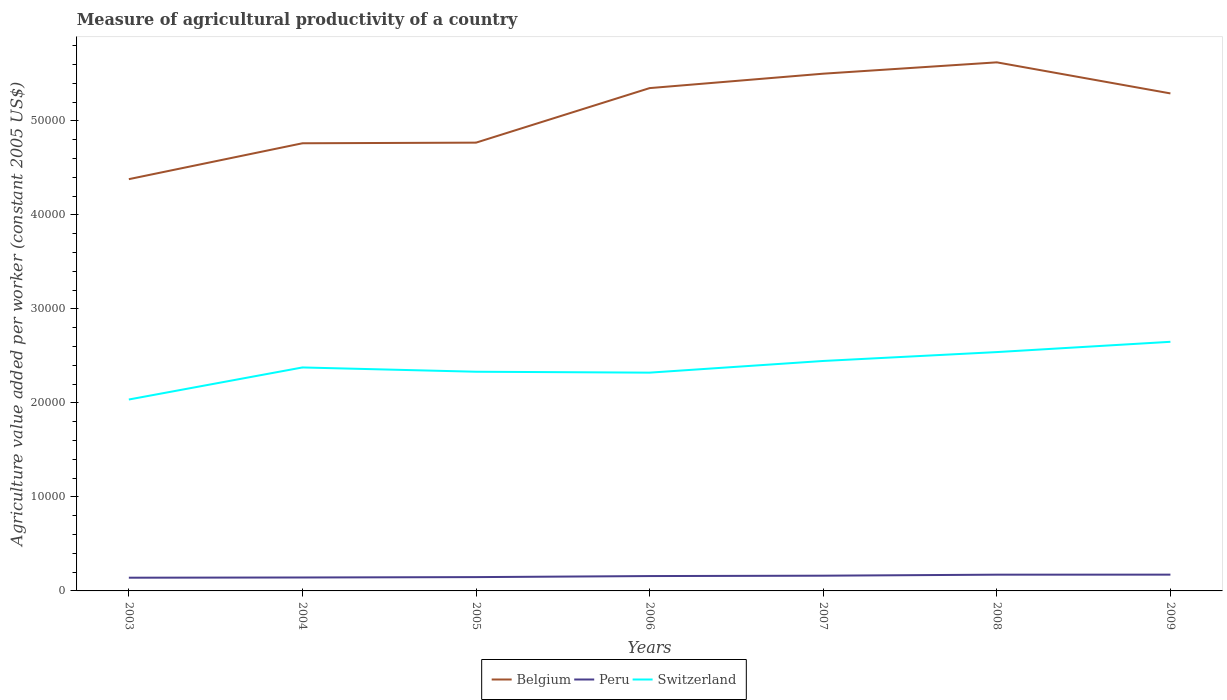Across all years, what is the maximum measure of agricultural productivity in Switzerland?
Give a very brief answer. 2.04e+04. In which year was the measure of agricultural productivity in Belgium maximum?
Your answer should be compact. 2003. What is the total measure of agricultural productivity in Switzerland in the graph?
Your answer should be compact. -2090.52. What is the difference between the highest and the second highest measure of agricultural productivity in Belgium?
Your answer should be compact. 1.24e+04. How many years are there in the graph?
Your response must be concise. 7. What is the difference between two consecutive major ticks on the Y-axis?
Offer a terse response. 10000. Are the values on the major ticks of Y-axis written in scientific E-notation?
Offer a terse response. No. What is the title of the graph?
Give a very brief answer. Measure of agricultural productivity of a country. What is the label or title of the Y-axis?
Your response must be concise. Agriculture value added per worker (constant 2005 US$). What is the Agriculture value added per worker (constant 2005 US$) in Belgium in 2003?
Keep it short and to the point. 4.38e+04. What is the Agriculture value added per worker (constant 2005 US$) in Peru in 2003?
Your answer should be very brief. 1405.11. What is the Agriculture value added per worker (constant 2005 US$) of Switzerland in 2003?
Offer a terse response. 2.04e+04. What is the Agriculture value added per worker (constant 2005 US$) of Belgium in 2004?
Make the answer very short. 4.76e+04. What is the Agriculture value added per worker (constant 2005 US$) of Peru in 2004?
Offer a very short reply. 1429.65. What is the Agriculture value added per worker (constant 2005 US$) in Switzerland in 2004?
Give a very brief answer. 2.38e+04. What is the Agriculture value added per worker (constant 2005 US$) of Belgium in 2005?
Your response must be concise. 4.77e+04. What is the Agriculture value added per worker (constant 2005 US$) of Peru in 2005?
Provide a short and direct response. 1468.91. What is the Agriculture value added per worker (constant 2005 US$) in Switzerland in 2005?
Keep it short and to the point. 2.33e+04. What is the Agriculture value added per worker (constant 2005 US$) in Belgium in 2006?
Offer a very short reply. 5.35e+04. What is the Agriculture value added per worker (constant 2005 US$) of Peru in 2006?
Your response must be concise. 1580.11. What is the Agriculture value added per worker (constant 2005 US$) of Switzerland in 2006?
Give a very brief answer. 2.32e+04. What is the Agriculture value added per worker (constant 2005 US$) of Belgium in 2007?
Your response must be concise. 5.50e+04. What is the Agriculture value added per worker (constant 2005 US$) in Peru in 2007?
Provide a succinct answer. 1620.17. What is the Agriculture value added per worker (constant 2005 US$) in Switzerland in 2007?
Ensure brevity in your answer.  2.45e+04. What is the Agriculture value added per worker (constant 2005 US$) of Belgium in 2008?
Provide a short and direct response. 5.62e+04. What is the Agriculture value added per worker (constant 2005 US$) of Peru in 2008?
Give a very brief answer. 1728.53. What is the Agriculture value added per worker (constant 2005 US$) of Switzerland in 2008?
Provide a succinct answer. 2.54e+04. What is the Agriculture value added per worker (constant 2005 US$) of Belgium in 2009?
Your answer should be compact. 5.29e+04. What is the Agriculture value added per worker (constant 2005 US$) in Peru in 2009?
Your answer should be compact. 1731.8. What is the Agriculture value added per worker (constant 2005 US$) of Switzerland in 2009?
Provide a succinct answer. 2.65e+04. Across all years, what is the maximum Agriculture value added per worker (constant 2005 US$) in Belgium?
Make the answer very short. 5.62e+04. Across all years, what is the maximum Agriculture value added per worker (constant 2005 US$) of Peru?
Give a very brief answer. 1731.8. Across all years, what is the maximum Agriculture value added per worker (constant 2005 US$) in Switzerland?
Make the answer very short. 2.65e+04. Across all years, what is the minimum Agriculture value added per worker (constant 2005 US$) in Belgium?
Give a very brief answer. 4.38e+04. Across all years, what is the minimum Agriculture value added per worker (constant 2005 US$) of Peru?
Offer a very short reply. 1405.11. Across all years, what is the minimum Agriculture value added per worker (constant 2005 US$) in Switzerland?
Give a very brief answer. 2.04e+04. What is the total Agriculture value added per worker (constant 2005 US$) in Belgium in the graph?
Provide a succinct answer. 3.57e+05. What is the total Agriculture value added per worker (constant 2005 US$) in Peru in the graph?
Your answer should be compact. 1.10e+04. What is the total Agriculture value added per worker (constant 2005 US$) of Switzerland in the graph?
Make the answer very short. 1.67e+05. What is the difference between the Agriculture value added per worker (constant 2005 US$) in Belgium in 2003 and that in 2004?
Your answer should be compact. -3816.6. What is the difference between the Agriculture value added per worker (constant 2005 US$) in Peru in 2003 and that in 2004?
Provide a succinct answer. -24.54. What is the difference between the Agriculture value added per worker (constant 2005 US$) in Switzerland in 2003 and that in 2004?
Offer a very short reply. -3411.15. What is the difference between the Agriculture value added per worker (constant 2005 US$) in Belgium in 2003 and that in 2005?
Offer a very short reply. -3883.5. What is the difference between the Agriculture value added per worker (constant 2005 US$) of Peru in 2003 and that in 2005?
Give a very brief answer. -63.8. What is the difference between the Agriculture value added per worker (constant 2005 US$) in Switzerland in 2003 and that in 2005?
Your response must be concise. -2954.77. What is the difference between the Agriculture value added per worker (constant 2005 US$) in Belgium in 2003 and that in 2006?
Keep it short and to the point. -9684.39. What is the difference between the Agriculture value added per worker (constant 2005 US$) of Peru in 2003 and that in 2006?
Your response must be concise. -175. What is the difference between the Agriculture value added per worker (constant 2005 US$) of Switzerland in 2003 and that in 2006?
Provide a succinct answer. -2858.29. What is the difference between the Agriculture value added per worker (constant 2005 US$) of Belgium in 2003 and that in 2007?
Keep it short and to the point. -1.12e+04. What is the difference between the Agriculture value added per worker (constant 2005 US$) in Peru in 2003 and that in 2007?
Your answer should be very brief. -215.07. What is the difference between the Agriculture value added per worker (constant 2005 US$) in Switzerland in 2003 and that in 2007?
Offer a terse response. -4101.01. What is the difference between the Agriculture value added per worker (constant 2005 US$) of Belgium in 2003 and that in 2008?
Offer a very short reply. -1.24e+04. What is the difference between the Agriculture value added per worker (constant 2005 US$) of Peru in 2003 and that in 2008?
Provide a succinct answer. -323.43. What is the difference between the Agriculture value added per worker (constant 2005 US$) in Switzerland in 2003 and that in 2008?
Provide a short and direct response. -5045.29. What is the difference between the Agriculture value added per worker (constant 2005 US$) of Belgium in 2003 and that in 2009?
Ensure brevity in your answer.  -9119.14. What is the difference between the Agriculture value added per worker (constant 2005 US$) of Peru in 2003 and that in 2009?
Your response must be concise. -326.69. What is the difference between the Agriculture value added per worker (constant 2005 US$) of Switzerland in 2003 and that in 2009?
Provide a succinct answer. -6139.39. What is the difference between the Agriculture value added per worker (constant 2005 US$) in Belgium in 2004 and that in 2005?
Make the answer very short. -66.9. What is the difference between the Agriculture value added per worker (constant 2005 US$) of Peru in 2004 and that in 2005?
Your response must be concise. -39.26. What is the difference between the Agriculture value added per worker (constant 2005 US$) in Switzerland in 2004 and that in 2005?
Ensure brevity in your answer.  456.39. What is the difference between the Agriculture value added per worker (constant 2005 US$) in Belgium in 2004 and that in 2006?
Keep it short and to the point. -5867.79. What is the difference between the Agriculture value added per worker (constant 2005 US$) in Peru in 2004 and that in 2006?
Give a very brief answer. -150.46. What is the difference between the Agriculture value added per worker (constant 2005 US$) of Switzerland in 2004 and that in 2006?
Your response must be concise. 552.86. What is the difference between the Agriculture value added per worker (constant 2005 US$) of Belgium in 2004 and that in 2007?
Provide a succinct answer. -7400.8. What is the difference between the Agriculture value added per worker (constant 2005 US$) in Peru in 2004 and that in 2007?
Ensure brevity in your answer.  -190.53. What is the difference between the Agriculture value added per worker (constant 2005 US$) in Switzerland in 2004 and that in 2007?
Make the answer very short. -689.86. What is the difference between the Agriculture value added per worker (constant 2005 US$) in Belgium in 2004 and that in 2008?
Keep it short and to the point. -8607.5. What is the difference between the Agriculture value added per worker (constant 2005 US$) in Peru in 2004 and that in 2008?
Make the answer very short. -298.89. What is the difference between the Agriculture value added per worker (constant 2005 US$) of Switzerland in 2004 and that in 2008?
Make the answer very short. -1634.13. What is the difference between the Agriculture value added per worker (constant 2005 US$) of Belgium in 2004 and that in 2009?
Your answer should be very brief. -5302.54. What is the difference between the Agriculture value added per worker (constant 2005 US$) of Peru in 2004 and that in 2009?
Offer a terse response. -302.15. What is the difference between the Agriculture value added per worker (constant 2005 US$) in Switzerland in 2004 and that in 2009?
Keep it short and to the point. -2728.24. What is the difference between the Agriculture value added per worker (constant 2005 US$) of Belgium in 2005 and that in 2006?
Offer a very short reply. -5800.89. What is the difference between the Agriculture value added per worker (constant 2005 US$) in Peru in 2005 and that in 2006?
Provide a short and direct response. -111.2. What is the difference between the Agriculture value added per worker (constant 2005 US$) of Switzerland in 2005 and that in 2006?
Provide a short and direct response. 96.47. What is the difference between the Agriculture value added per worker (constant 2005 US$) in Belgium in 2005 and that in 2007?
Provide a succinct answer. -7333.89. What is the difference between the Agriculture value added per worker (constant 2005 US$) in Peru in 2005 and that in 2007?
Your response must be concise. -151.27. What is the difference between the Agriculture value added per worker (constant 2005 US$) in Switzerland in 2005 and that in 2007?
Your answer should be very brief. -1146.24. What is the difference between the Agriculture value added per worker (constant 2005 US$) of Belgium in 2005 and that in 2008?
Your answer should be very brief. -8540.59. What is the difference between the Agriculture value added per worker (constant 2005 US$) of Peru in 2005 and that in 2008?
Keep it short and to the point. -259.63. What is the difference between the Agriculture value added per worker (constant 2005 US$) of Switzerland in 2005 and that in 2008?
Make the answer very short. -2090.52. What is the difference between the Agriculture value added per worker (constant 2005 US$) of Belgium in 2005 and that in 2009?
Your answer should be compact. -5235.64. What is the difference between the Agriculture value added per worker (constant 2005 US$) in Peru in 2005 and that in 2009?
Your answer should be compact. -262.89. What is the difference between the Agriculture value added per worker (constant 2005 US$) in Switzerland in 2005 and that in 2009?
Offer a very short reply. -3184.63. What is the difference between the Agriculture value added per worker (constant 2005 US$) in Belgium in 2006 and that in 2007?
Your answer should be compact. -1533.01. What is the difference between the Agriculture value added per worker (constant 2005 US$) of Peru in 2006 and that in 2007?
Your answer should be compact. -40.07. What is the difference between the Agriculture value added per worker (constant 2005 US$) in Switzerland in 2006 and that in 2007?
Keep it short and to the point. -1242.72. What is the difference between the Agriculture value added per worker (constant 2005 US$) of Belgium in 2006 and that in 2008?
Provide a short and direct response. -2739.71. What is the difference between the Agriculture value added per worker (constant 2005 US$) of Peru in 2006 and that in 2008?
Your answer should be very brief. -148.43. What is the difference between the Agriculture value added per worker (constant 2005 US$) in Switzerland in 2006 and that in 2008?
Give a very brief answer. -2186.99. What is the difference between the Agriculture value added per worker (constant 2005 US$) of Belgium in 2006 and that in 2009?
Provide a succinct answer. 565.25. What is the difference between the Agriculture value added per worker (constant 2005 US$) in Peru in 2006 and that in 2009?
Provide a succinct answer. -151.69. What is the difference between the Agriculture value added per worker (constant 2005 US$) of Switzerland in 2006 and that in 2009?
Your answer should be very brief. -3281.1. What is the difference between the Agriculture value added per worker (constant 2005 US$) in Belgium in 2007 and that in 2008?
Provide a short and direct response. -1206.7. What is the difference between the Agriculture value added per worker (constant 2005 US$) of Peru in 2007 and that in 2008?
Offer a very short reply. -108.36. What is the difference between the Agriculture value added per worker (constant 2005 US$) of Switzerland in 2007 and that in 2008?
Offer a terse response. -944.28. What is the difference between the Agriculture value added per worker (constant 2005 US$) of Belgium in 2007 and that in 2009?
Offer a very short reply. 2098.26. What is the difference between the Agriculture value added per worker (constant 2005 US$) in Peru in 2007 and that in 2009?
Provide a succinct answer. -111.62. What is the difference between the Agriculture value added per worker (constant 2005 US$) in Switzerland in 2007 and that in 2009?
Keep it short and to the point. -2038.38. What is the difference between the Agriculture value added per worker (constant 2005 US$) in Belgium in 2008 and that in 2009?
Your answer should be very brief. 3304.95. What is the difference between the Agriculture value added per worker (constant 2005 US$) in Peru in 2008 and that in 2009?
Keep it short and to the point. -3.26. What is the difference between the Agriculture value added per worker (constant 2005 US$) of Switzerland in 2008 and that in 2009?
Provide a succinct answer. -1094.11. What is the difference between the Agriculture value added per worker (constant 2005 US$) of Belgium in 2003 and the Agriculture value added per worker (constant 2005 US$) of Peru in 2004?
Give a very brief answer. 4.24e+04. What is the difference between the Agriculture value added per worker (constant 2005 US$) in Belgium in 2003 and the Agriculture value added per worker (constant 2005 US$) in Switzerland in 2004?
Your response must be concise. 2.00e+04. What is the difference between the Agriculture value added per worker (constant 2005 US$) of Peru in 2003 and the Agriculture value added per worker (constant 2005 US$) of Switzerland in 2004?
Your answer should be very brief. -2.24e+04. What is the difference between the Agriculture value added per worker (constant 2005 US$) in Belgium in 2003 and the Agriculture value added per worker (constant 2005 US$) in Peru in 2005?
Provide a succinct answer. 4.23e+04. What is the difference between the Agriculture value added per worker (constant 2005 US$) in Belgium in 2003 and the Agriculture value added per worker (constant 2005 US$) in Switzerland in 2005?
Your answer should be compact. 2.05e+04. What is the difference between the Agriculture value added per worker (constant 2005 US$) of Peru in 2003 and the Agriculture value added per worker (constant 2005 US$) of Switzerland in 2005?
Provide a short and direct response. -2.19e+04. What is the difference between the Agriculture value added per worker (constant 2005 US$) in Belgium in 2003 and the Agriculture value added per worker (constant 2005 US$) in Peru in 2006?
Your answer should be very brief. 4.22e+04. What is the difference between the Agriculture value added per worker (constant 2005 US$) in Belgium in 2003 and the Agriculture value added per worker (constant 2005 US$) in Switzerland in 2006?
Give a very brief answer. 2.06e+04. What is the difference between the Agriculture value added per worker (constant 2005 US$) of Peru in 2003 and the Agriculture value added per worker (constant 2005 US$) of Switzerland in 2006?
Your answer should be very brief. -2.18e+04. What is the difference between the Agriculture value added per worker (constant 2005 US$) of Belgium in 2003 and the Agriculture value added per worker (constant 2005 US$) of Peru in 2007?
Offer a terse response. 4.22e+04. What is the difference between the Agriculture value added per worker (constant 2005 US$) of Belgium in 2003 and the Agriculture value added per worker (constant 2005 US$) of Switzerland in 2007?
Ensure brevity in your answer.  1.93e+04. What is the difference between the Agriculture value added per worker (constant 2005 US$) of Peru in 2003 and the Agriculture value added per worker (constant 2005 US$) of Switzerland in 2007?
Make the answer very short. -2.31e+04. What is the difference between the Agriculture value added per worker (constant 2005 US$) of Belgium in 2003 and the Agriculture value added per worker (constant 2005 US$) of Peru in 2008?
Offer a terse response. 4.21e+04. What is the difference between the Agriculture value added per worker (constant 2005 US$) in Belgium in 2003 and the Agriculture value added per worker (constant 2005 US$) in Switzerland in 2008?
Your answer should be very brief. 1.84e+04. What is the difference between the Agriculture value added per worker (constant 2005 US$) of Peru in 2003 and the Agriculture value added per worker (constant 2005 US$) of Switzerland in 2008?
Offer a terse response. -2.40e+04. What is the difference between the Agriculture value added per worker (constant 2005 US$) in Belgium in 2003 and the Agriculture value added per worker (constant 2005 US$) in Peru in 2009?
Provide a succinct answer. 4.21e+04. What is the difference between the Agriculture value added per worker (constant 2005 US$) in Belgium in 2003 and the Agriculture value added per worker (constant 2005 US$) in Switzerland in 2009?
Provide a short and direct response. 1.73e+04. What is the difference between the Agriculture value added per worker (constant 2005 US$) of Peru in 2003 and the Agriculture value added per worker (constant 2005 US$) of Switzerland in 2009?
Provide a succinct answer. -2.51e+04. What is the difference between the Agriculture value added per worker (constant 2005 US$) in Belgium in 2004 and the Agriculture value added per worker (constant 2005 US$) in Peru in 2005?
Provide a short and direct response. 4.61e+04. What is the difference between the Agriculture value added per worker (constant 2005 US$) in Belgium in 2004 and the Agriculture value added per worker (constant 2005 US$) in Switzerland in 2005?
Your answer should be compact. 2.43e+04. What is the difference between the Agriculture value added per worker (constant 2005 US$) of Peru in 2004 and the Agriculture value added per worker (constant 2005 US$) of Switzerland in 2005?
Your response must be concise. -2.19e+04. What is the difference between the Agriculture value added per worker (constant 2005 US$) of Belgium in 2004 and the Agriculture value added per worker (constant 2005 US$) of Peru in 2006?
Your answer should be compact. 4.60e+04. What is the difference between the Agriculture value added per worker (constant 2005 US$) in Belgium in 2004 and the Agriculture value added per worker (constant 2005 US$) in Switzerland in 2006?
Offer a very short reply. 2.44e+04. What is the difference between the Agriculture value added per worker (constant 2005 US$) of Peru in 2004 and the Agriculture value added per worker (constant 2005 US$) of Switzerland in 2006?
Your answer should be very brief. -2.18e+04. What is the difference between the Agriculture value added per worker (constant 2005 US$) of Belgium in 2004 and the Agriculture value added per worker (constant 2005 US$) of Peru in 2007?
Provide a short and direct response. 4.60e+04. What is the difference between the Agriculture value added per worker (constant 2005 US$) of Belgium in 2004 and the Agriculture value added per worker (constant 2005 US$) of Switzerland in 2007?
Your response must be concise. 2.32e+04. What is the difference between the Agriculture value added per worker (constant 2005 US$) in Peru in 2004 and the Agriculture value added per worker (constant 2005 US$) in Switzerland in 2007?
Give a very brief answer. -2.30e+04. What is the difference between the Agriculture value added per worker (constant 2005 US$) in Belgium in 2004 and the Agriculture value added per worker (constant 2005 US$) in Peru in 2008?
Offer a very short reply. 4.59e+04. What is the difference between the Agriculture value added per worker (constant 2005 US$) in Belgium in 2004 and the Agriculture value added per worker (constant 2005 US$) in Switzerland in 2008?
Your answer should be compact. 2.22e+04. What is the difference between the Agriculture value added per worker (constant 2005 US$) in Peru in 2004 and the Agriculture value added per worker (constant 2005 US$) in Switzerland in 2008?
Provide a succinct answer. -2.40e+04. What is the difference between the Agriculture value added per worker (constant 2005 US$) in Belgium in 2004 and the Agriculture value added per worker (constant 2005 US$) in Peru in 2009?
Your answer should be very brief. 4.59e+04. What is the difference between the Agriculture value added per worker (constant 2005 US$) of Belgium in 2004 and the Agriculture value added per worker (constant 2005 US$) of Switzerland in 2009?
Ensure brevity in your answer.  2.11e+04. What is the difference between the Agriculture value added per worker (constant 2005 US$) in Peru in 2004 and the Agriculture value added per worker (constant 2005 US$) in Switzerland in 2009?
Your response must be concise. -2.51e+04. What is the difference between the Agriculture value added per worker (constant 2005 US$) in Belgium in 2005 and the Agriculture value added per worker (constant 2005 US$) in Peru in 2006?
Provide a short and direct response. 4.61e+04. What is the difference between the Agriculture value added per worker (constant 2005 US$) of Belgium in 2005 and the Agriculture value added per worker (constant 2005 US$) of Switzerland in 2006?
Provide a succinct answer. 2.45e+04. What is the difference between the Agriculture value added per worker (constant 2005 US$) in Peru in 2005 and the Agriculture value added per worker (constant 2005 US$) in Switzerland in 2006?
Ensure brevity in your answer.  -2.17e+04. What is the difference between the Agriculture value added per worker (constant 2005 US$) in Belgium in 2005 and the Agriculture value added per worker (constant 2005 US$) in Peru in 2007?
Your answer should be compact. 4.61e+04. What is the difference between the Agriculture value added per worker (constant 2005 US$) in Belgium in 2005 and the Agriculture value added per worker (constant 2005 US$) in Switzerland in 2007?
Provide a succinct answer. 2.32e+04. What is the difference between the Agriculture value added per worker (constant 2005 US$) in Peru in 2005 and the Agriculture value added per worker (constant 2005 US$) in Switzerland in 2007?
Your answer should be compact. -2.30e+04. What is the difference between the Agriculture value added per worker (constant 2005 US$) in Belgium in 2005 and the Agriculture value added per worker (constant 2005 US$) in Peru in 2008?
Your answer should be very brief. 4.59e+04. What is the difference between the Agriculture value added per worker (constant 2005 US$) of Belgium in 2005 and the Agriculture value added per worker (constant 2005 US$) of Switzerland in 2008?
Offer a terse response. 2.23e+04. What is the difference between the Agriculture value added per worker (constant 2005 US$) of Peru in 2005 and the Agriculture value added per worker (constant 2005 US$) of Switzerland in 2008?
Your response must be concise. -2.39e+04. What is the difference between the Agriculture value added per worker (constant 2005 US$) in Belgium in 2005 and the Agriculture value added per worker (constant 2005 US$) in Peru in 2009?
Ensure brevity in your answer.  4.59e+04. What is the difference between the Agriculture value added per worker (constant 2005 US$) in Belgium in 2005 and the Agriculture value added per worker (constant 2005 US$) in Switzerland in 2009?
Your answer should be very brief. 2.12e+04. What is the difference between the Agriculture value added per worker (constant 2005 US$) of Peru in 2005 and the Agriculture value added per worker (constant 2005 US$) of Switzerland in 2009?
Your response must be concise. -2.50e+04. What is the difference between the Agriculture value added per worker (constant 2005 US$) of Belgium in 2006 and the Agriculture value added per worker (constant 2005 US$) of Peru in 2007?
Make the answer very short. 5.19e+04. What is the difference between the Agriculture value added per worker (constant 2005 US$) in Belgium in 2006 and the Agriculture value added per worker (constant 2005 US$) in Switzerland in 2007?
Offer a very short reply. 2.90e+04. What is the difference between the Agriculture value added per worker (constant 2005 US$) in Peru in 2006 and the Agriculture value added per worker (constant 2005 US$) in Switzerland in 2007?
Provide a succinct answer. -2.29e+04. What is the difference between the Agriculture value added per worker (constant 2005 US$) of Belgium in 2006 and the Agriculture value added per worker (constant 2005 US$) of Peru in 2008?
Your answer should be compact. 5.18e+04. What is the difference between the Agriculture value added per worker (constant 2005 US$) of Belgium in 2006 and the Agriculture value added per worker (constant 2005 US$) of Switzerland in 2008?
Give a very brief answer. 2.81e+04. What is the difference between the Agriculture value added per worker (constant 2005 US$) in Peru in 2006 and the Agriculture value added per worker (constant 2005 US$) in Switzerland in 2008?
Give a very brief answer. -2.38e+04. What is the difference between the Agriculture value added per worker (constant 2005 US$) of Belgium in 2006 and the Agriculture value added per worker (constant 2005 US$) of Peru in 2009?
Provide a short and direct response. 5.17e+04. What is the difference between the Agriculture value added per worker (constant 2005 US$) in Belgium in 2006 and the Agriculture value added per worker (constant 2005 US$) in Switzerland in 2009?
Your answer should be very brief. 2.70e+04. What is the difference between the Agriculture value added per worker (constant 2005 US$) in Peru in 2006 and the Agriculture value added per worker (constant 2005 US$) in Switzerland in 2009?
Give a very brief answer. -2.49e+04. What is the difference between the Agriculture value added per worker (constant 2005 US$) in Belgium in 2007 and the Agriculture value added per worker (constant 2005 US$) in Peru in 2008?
Your answer should be compact. 5.33e+04. What is the difference between the Agriculture value added per worker (constant 2005 US$) in Belgium in 2007 and the Agriculture value added per worker (constant 2005 US$) in Switzerland in 2008?
Your response must be concise. 2.96e+04. What is the difference between the Agriculture value added per worker (constant 2005 US$) of Peru in 2007 and the Agriculture value added per worker (constant 2005 US$) of Switzerland in 2008?
Give a very brief answer. -2.38e+04. What is the difference between the Agriculture value added per worker (constant 2005 US$) of Belgium in 2007 and the Agriculture value added per worker (constant 2005 US$) of Peru in 2009?
Offer a terse response. 5.33e+04. What is the difference between the Agriculture value added per worker (constant 2005 US$) of Belgium in 2007 and the Agriculture value added per worker (constant 2005 US$) of Switzerland in 2009?
Give a very brief answer. 2.85e+04. What is the difference between the Agriculture value added per worker (constant 2005 US$) of Peru in 2007 and the Agriculture value added per worker (constant 2005 US$) of Switzerland in 2009?
Your answer should be very brief. -2.49e+04. What is the difference between the Agriculture value added per worker (constant 2005 US$) in Belgium in 2008 and the Agriculture value added per worker (constant 2005 US$) in Peru in 2009?
Your answer should be compact. 5.45e+04. What is the difference between the Agriculture value added per worker (constant 2005 US$) in Belgium in 2008 and the Agriculture value added per worker (constant 2005 US$) in Switzerland in 2009?
Provide a succinct answer. 2.97e+04. What is the difference between the Agriculture value added per worker (constant 2005 US$) in Peru in 2008 and the Agriculture value added per worker (constant 2005 US$) in Switzerland in 2009?
Provide a short and direct response. -2.48e+04. What is the average Agriculture value added per worker (constant 2005 US$) of Belgium per year?
Offer a very short reply. 5.10e+04. What is the average Agriculture value added per worker (constant 2005 US$) in Peru per year?
Make the answer very short. 1566.32. What is the average Agriculture value added per worker (constant 2005 US$) of Switzerland per year?
Give a very brief answer. 2.39e+04. In the year 2003, what is the difference between the Agriculture value added per worker (constant 2005 US$) of Belgium and Agriculture value added per worker (constant 2005 US$) of Peru?
Provide a succinct answer. 4.24e+04. In the year 2003, what is the difference between the Agriculture value added per worker (constant 2005 US$) of Belgium and Agriculture value added per worker (constant 2005 US$) of Switzerland?
Your answer should be very brief. 2.34e+04. In the year 2003, what is the difference between the Agriculture value added per worker (constant 2005 US$) in Peru and Agriculture value added per worker (constant 2005 US$) in Switzerland?
Make the answer very short. -1.90e+04. In the year 2004, what is the difference between the Agriculture value added per worker (constant 2005 US$) of Belgium and Agriculture value added per worker (constant 2005 US$) of Peru?
Keep it short and to the point. 4.62e+04. In the year 2004, what is the difference between the Agriculture value added per worker (constant 2005 US$) in Belgium and Agriculture value added per worker (constant 2005 US$) in Switzerland?
Offer a very short reply. 2.38e+04. In the year 2004, what is the difference between the Agriculture value added per worker (constant 2005 US$) of Peru and Agriculture value added per worker (constant 2005 US$) of Switzerland?
Ensure brevity in your answer.  -2.23e+04. In the year 2005, what is the difference between the Agriculture value added per worker (constant 2005 US$) of Belgium and Agriculture value added per worker (constant 2005 US$) of Peru?
Your answer should be very brief. 4.62e+04. In the year 2005, what is the difference between the Agriculture value added per worker (constant 2005 US$) of Belgium and Agriculture value added per worker (constant 2005 US$) of Switzerland?
Your answer should be very brief. 2.44e+04. In the year 2005, what is the difference between the Agriculture value added per worker (constant 2005 US$) in Peru and Agriculture value added per worker (constant 2005 US$) in Switzerland?
Provide a short and direct response. -2.18e+04. In the year 2006, what is the difference between the Agriculture value added per worker (constant 2005 US$) in Belgium and Agriculture value added per worker (constant 2005 US$) in Peru?
Offer a very short reply. 5.19e+04. In the year 2006, what is the difference between the Agriculture value added per worker (constant 2005 US$) of Belgium and Agriculture value added per worker (constant 2005 US$) of Switzerland?
Provide a succinct answer. 3.03e+04. In the year 2006, what is the difference between the Agriculture value added per worker (constant 2005 US$) in Peru and Agriculture value added per worker (constant 2005 US$) in Switzerland?
Your answer should be compact. -2.16e+04. In the year 2007, what is the difference between the Agriculture value added per worker (constant 2005 US$) of Belgium and Agriculture value added per worker (constant 2005 US$) of Peru?
Ensure brevity in your answer.  5.34e+04. In the year 2007, what is the difference between the Agriculture value added per worker (constant 2005 US$) of Belgium and Agriculture value added per worker (constant 2005 US$) of Switzerland?
Offer a terse response. 3.06e+04. In the year 2007, what is the difference between the Agriculture value added per worker (constant 2005 US$) in Peru and Agriculture value added per worker (constant 2005 US$) in Switzerland?
Ensure brevity in your answer.  -2.28e+04. In the year 2008, what is the difference between the Agriculture value added per worker (constant 2005 US$) in Belgium and Agriculture value added per worker (constant 2005 US$) in Peru?
Give a very brief answer. 5.45e+04. In the year 2008, what is the difference between the Agriculture value added per worker (constant 2005 US$) in Belgium and Agriculture value added per worker (constant 2005 US$) in Switzerland?
Provide a succinct answer. 3.08e+04. In the year 2008, what is the difference between the Agriculture value added per worker (constant 2005 US$) in Peru and Agriculture value added per worker (constant 2005 US$) in Switzerland?
Ensure brevity in your answer.  -2.37e+04. In the year 2009, what is the difference between the Agriculture value added per worker (constant 2005 US$) in Belgium and Agriculture value added per worker (constant 2005 US$) in Peru?
Ensure brevity in your answer.  5.12e+04. In the year 2009, what is the difference between the Agriculture value added per worker (constant 2005 US$) in Belgium and Agriculture value added per worker (constant 2005 US$) in Switzerland?
Ensure brevity in your answer.  2.64e+04. In the year 2009, what is the difference between the Agriculture value added per worker (constant 2005 US$) in Peru and Agriculture value added per worker (constant 2005 US$) in Switzerland?
Your answer should be compact. -2.48e+04. What is the ratio of the Agriculture value added per worker (constant 2005 US$) in Belgium in 2003 to that in 2004?
Provide a short and direct response. 0.92. What is the ratio of the Agriculture value added per worker (constant 2005 US$) of Peru in 2003 to that in 2004?
Offer a very short reply. 0.98. What is the ratio of the Agriculture value added per worker (constant 2005 US$) in Switzerland in 2003 to that in 2004?
Give a very brief answer. 0.86. What is the ratio of the Agriculture value added per worker (constant 2005 US$) in Belgium in 2003 to that in 2005?
Keep it short and to the point. 0.92. What is the ratio of the Agriculture value added per worker (constant 2005 US$) of Peru in 2003 to that in 2005?
Make the answer very short. 0.96. What is the ratio of the Agriculture value added per worker (constant 2005 US$) in Switzerland in 2003 to that in 2005?
Offer a terse response. 0.87. What is the ratio of the Agriculture value added per worker (constant 2005 US$) in Belgium in 2003 to that in 2006?
Offer a terse response. 0.82. What is the ratio of the Agriculture value added per worker (constant 2005 US$) of Peru in 2003 to that in 2006?
Offer a very short reply. 0.89. What is the ratio of the Agriculture value added per worker (constant 2005 US$) in Switzerland in 2003 to that in 2006?
Your answer should be compact. 0.88. What is the ratio of the Agriculture value added per worker (constant 2005 US$) in Belgium in 2003 to that in 2007?
Ensure brevity in your answer.  0.8. What is the ratio of the Agriculture value added per worker (constant 2005 US$) of Peru in 2003 to that in 2007?
Offer a very short reply. 0.87. What is the ratio of the Agriculture value added per worker (constant 2005 US$) in Switzerland in 2003 to that in 2007?
Your response must be concise. 0.83. What is the ratio of the Agriculture value added per worker (constant 2005 US$) in Belgium in 2003 to that in 2008?
Provide a succinct answer. 0.78. What is the ratio of the Agriculture value added per worker (constant 2005 US$) of Peru in 2003 to that in 2008?
Ensure brevity in your answer.  0.81. What is the ratio of the Agriculture value added per worker (constant 2005 US$) in Switzerland in 2003 to that in 2008?
Keep it short and to the point. 0.8. What is the ratio of the Agriculture value added per worker (constant 2005 US$) of Belgium in 2003 to that in 2009?
Provide a short and direct response. 0.83. What is the ratio of the Agriculture value added per worker (constant 2005 US$) in Peru in 2003 to that in 2009?
Provide a succinct answer. 0.81. What is the ratio of the Agriculture value added per worker (constant 2005 US$) in Switzerland in 2003 to that in 2009?
Your answer should be very brief. 0.77. What is the ratio of the Agriculture value added per worker (constant 2005 US$) in Belgium in 2004 to that in 2005?
Offer a terse response. 1. What is the ratio of the Agriculture value added per worker (constant 2005 US$) in Peru in 2004 to that in 2005?
Your answer should be compact. 0.97. What is the ratio of the Agriculture value added per worker (constant 2005 US$) in Switzerland in 2004 to that in 2005?
Make the answer very short. 1.02. What is the ratio of the Agriculture value added per worker (constant 2005 US$) of Belgium in 2004 to that in 2006?
Make the answer very short. 0.89. What is the ratio of the Agriculture value added per worker (constant 2005 US$) of Peru in 2004 to that in 2006?
Your answer should be very brief. 0.9. What is the ratio of the Agriculture value added per worker (constant 2005 US$) in Switzerland in 2004 to that in 2006?
Offer a terse response. 1.02. What is the ratio of the Agriculture value added per worker (constant 2005 US$) in Belgium in 2004 to that in 2007?
Offer a terse response. 0.87. What is the ratio of the Agriculture value added per worker (constant 2005 US$) in Peru in 2004 to that in 2007?
Ensure brevity in your answer.  0.88. What is the ratio of the Agriculture value added per worker (constant 2005 US$) in Switzerland in 2004 to that in 2007?
Your answer should be compact. 0.97. What is the ratio of the Agriculture value added per worker (constant 2005 US$) in Belgium in 2004 to that in 2008?
Offer a terse response. 0.85. What is the ratio of the Agriculture value added per worker (constant 2005 US$) of Peru in 2004 to that in 2008?
Your response must be concise. 0.83. What is the ratio of the Agriculture value added per worker (constant 2005 US$) of Switzerland in 2004 to that in 2008?
Make the answer very short. 0.94. What is the ratio of the Agriculture value added per worker (constant 2005 US$) of Belgium in 2004 to that in 2009?
Your answer should be very brief. 0.9. What is the ratio of the Agriculture value added per worker (constant 2005 US$) in Peru in 2004 to that in 2009?
Your answer should be compact. 0.83. What is the ratio of the Agriculture value added per worker (constant 2005 US$) of Switzerland in 2004 to that in 2009?
Provide a short and direct response. 0.9. What is the ratio of the Agriculture value added per worker (constant 2005 US$) of Belgium in 2005 to that in 2006?
Provide a short and direct response. 0.89. What is the ratio of the Agriculture value added per worker (constant 2005 US$) in Peru in 2005 to that in 2006?
Ensure brevity in your answer.  0.93. What is the ratio of the Agriculture value added per worker (constant 2005 US$) of Switzerland in 2005 to that in 2006?
Make the answer very short. 1. What is the ratio of the Agriculture value added per worker (constant 2005 US$) in Belgium in 2005 to that in 2007?
Ensure brevity in your answer.  0.87. What is the ratio of the Agriculture value added per worker (constant 2005 US$) in Peru in 2005 to that in 2007?
Your answer should be very brief. 0.91. What is the ratio of the Agriculture value added per worker (constant 2005 US$) in Switzerland in 2005 to that in 2007?
Give a very brief answer. 0.95. What is the ratio of the Agriculture value added per worker (constant 2005 US$) of Belgium in 2005 to that in 2008?
Your answer should be very brief. 0.85. What is the ratio of the Agriculture value added per worker (constant 2005 US$) in Peru in 2005 to that in 2008?
Keep it short and to the point. 0.85. What is the ratio of the Agriculture value added per worker (constant 2005 US$) in Switzerland in 2005 to that in 2008?
Keep it short and to the point. 0.92. What is the ratio of the Agriculture value added per worker (constant 2005 US$) in Belgium in 2005 to that in 2009?
Provide a short and direct response. 0.9. What is the ratio of the Agriculture value added per worker (constant 2005 US$) in Peru in 2005 to that in 2009?
Provide a succinct answer. 0.85. What is the ratio of the Agriculture value added per worker (constant 2005 US$) in Switzerland in 2005 to that in 2009?
Give a very brief answer. 0.88. What is the ratio of the Agriculture value added per worker (constant 2005 US$) of Belgium in 2006 to that in 2007?
Give a very brief answer. 0.97. What is the ratio of the Agriculture value added per worker (constant 2005 US$) in Peru in 2006 to that in 2007?
Offer a terse response. 0.98. What is the ratio of the Agriculture value added per worker (constant 2005 US$) in Switzerland in 2006 to that in 2007?
Give a very brief answer. 0.95. What is the ratio of the Agriculture value added per worker (constant 2005 US$) of Belgium in 2006 to that in 2008?
Your answer should be compact. 0.95. What is the ratio of the Agriculture value added per worker (constant 2005 US$) of Peru in 2006 to that in 2008?
Offer a terse response. 0.91. What is the ratio of the Agriculture value added per worker (constant 2005 US$) in Switzerland in 2006 to that in 2008?
Give a very brief answer. 0.91. What is the ratio of the Agriculture value added per worker (constant 2005 US$) of Belgium in 2006 to that in 2009?
Provide a short and direct response. 1.01. What is the ratio of the Agriculture value added per worker (constant 2005 US$) in Peru in 2006 to that in 2009?
Your answer should be compact. 0.91. What is the ratio of the Agriculture value added per worker (constant 2005 US$) in Switzerland in 2006 to that in 2009?
Your answer should be very brief. 0.88. What is the ratio of the Agriculture value added per worker (constant 2005 US$) in Belgium in 2007 to that in 2008?
Provide a succinct answer. 0.98. What is the ratio of the Agriculture value added per worker (constant 2005 US$) in Peru in 2007 to that in 2008?
Give a very brief answer. 0.94. What is the ratio of the Agriculture value added per worker (constant 2005 US$) in Switzerland in 2007 to that in 2008?
Provide a short and direct response. 0.96. What is the ratio of the Agriculture value added per worker (constant 2005 US$) in Belgium in 2007 to that in 2009?
Give a very brief answer. 1.04. What is the ratio of the Agriculture value added per worker (constant 2005 US$) in Peru in 2007 to that in 2009?
Offer a terse response. 0.94. What is the ratio of the Agriculture value added per worker (constant 2005 US$) of Peru in 2008 to that in 2009?
Keep it short and to the point. 1. What is the ratio of the Agriculture value added per worker (constant 2005 US$) of Switzerland in 2008 to that in 2009?
Give a very brief answer. 0.96. What is the difference between the highest and the second highest Agriculture value added per worker (constant 2005 US$) in Belgium?
Make the answer very short. 1206.7. What is the difference between the highest and the second highest Agriculture value added per worker (constant 2005 US$) of Peru?
Your answer should be very brief. 3.26. What is the difference between the highest and the second highest Agriculture value added per worker (constant 2005 US$) of Switzerland?
Ensure brevity in your answer.  1094.11. What is the difference between the highest and the lowest Agriculture value added per worker (constant 2005 US$) of Belgium?
Offer a very short reply. 1.24e+04. What is the difference between the highest and the lowest Agriculture value added per worker (constant 2005 US$) of Peru?
Provide a short and direct response. 326.69. What is the difference between the highest and the lowest Agriculture value added per worker (constant 2005 US$) of Switzerland?
Provide a short and direct response. 6139.39. 